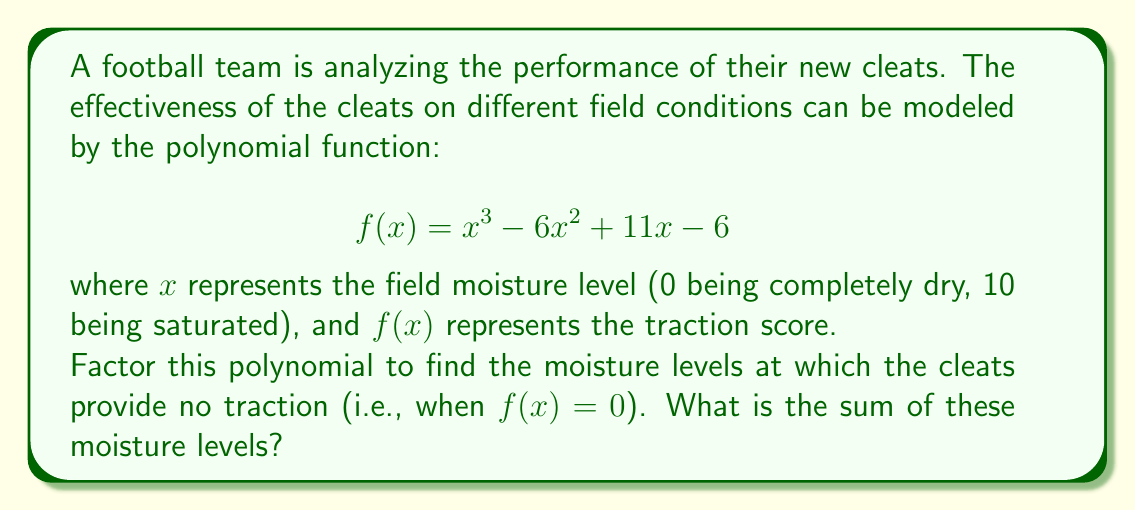Teach me how to tackle this problem. Let's approach this step-by-step:

1) We need to factor the polynomial $f(x) = x^3 - 6x^2 + 11x - 6$

2) This is a cubic polynomial. Let's try to guess one factor first. We can see that when $x = 1$, $f(1) = 1 - 6 + 11 - 6 = 0$. So $(x-1)$ is a factor.

3) We can divide $f(x)$ by $(x-1)$ to get the other factor:

   $x^3 - 6x^2 + 11x - 6 = (x-1)(x^2 - 5x + 6)$

4) Now we need to factor $x^2 - 5x + 6$. This is a quadratic expression.

5) We're looking for two numbers that multiply to give 6 and add to give -5. These numbers are -2 and -3.

6) So, $x^2 - 5x + 6 = (x-2)(x-3)$

7) Therefore, the complete factorization is:

   $f(x) = (x-1)(x-2)(x-3)$

8) The roots of this polynomial (where $f(x) = 0$) are $x = 1$, $x = 2$, and $x = 3$

9) The sum of these roots is $1 + 2 + 3 = 6$

Therefore, the sum of the moisture levels at which the cleats provide no traction is 6.
Answer: 6 